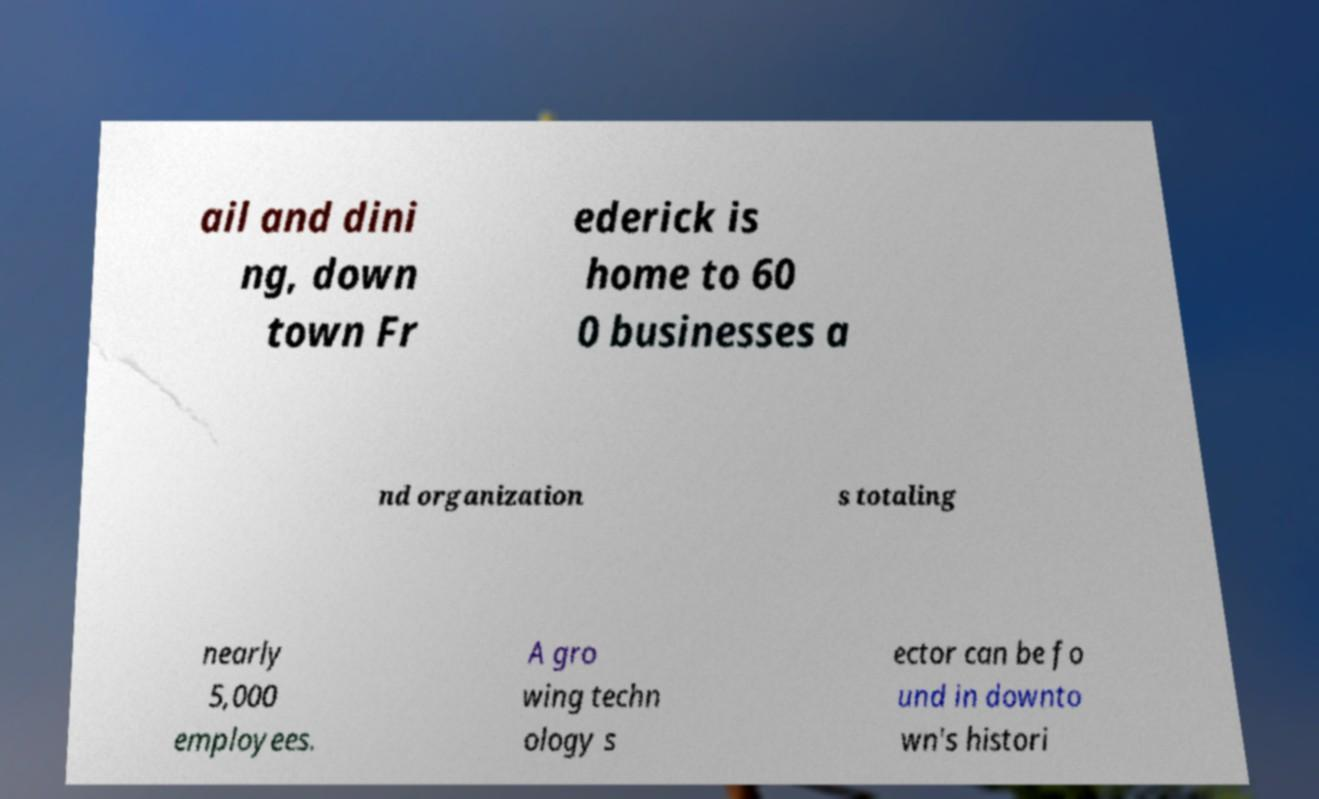Can you read and provide the text displayed in the image?This photo seems to have some interesting text. Can you extract and type it out for me? ail and dini ng, down town Fr ederick is home to 60 0 businesses a nd organization s totaling nearly 5,000 employees. A gro wing techn ology s ector can be fo und in downto wn's histori 